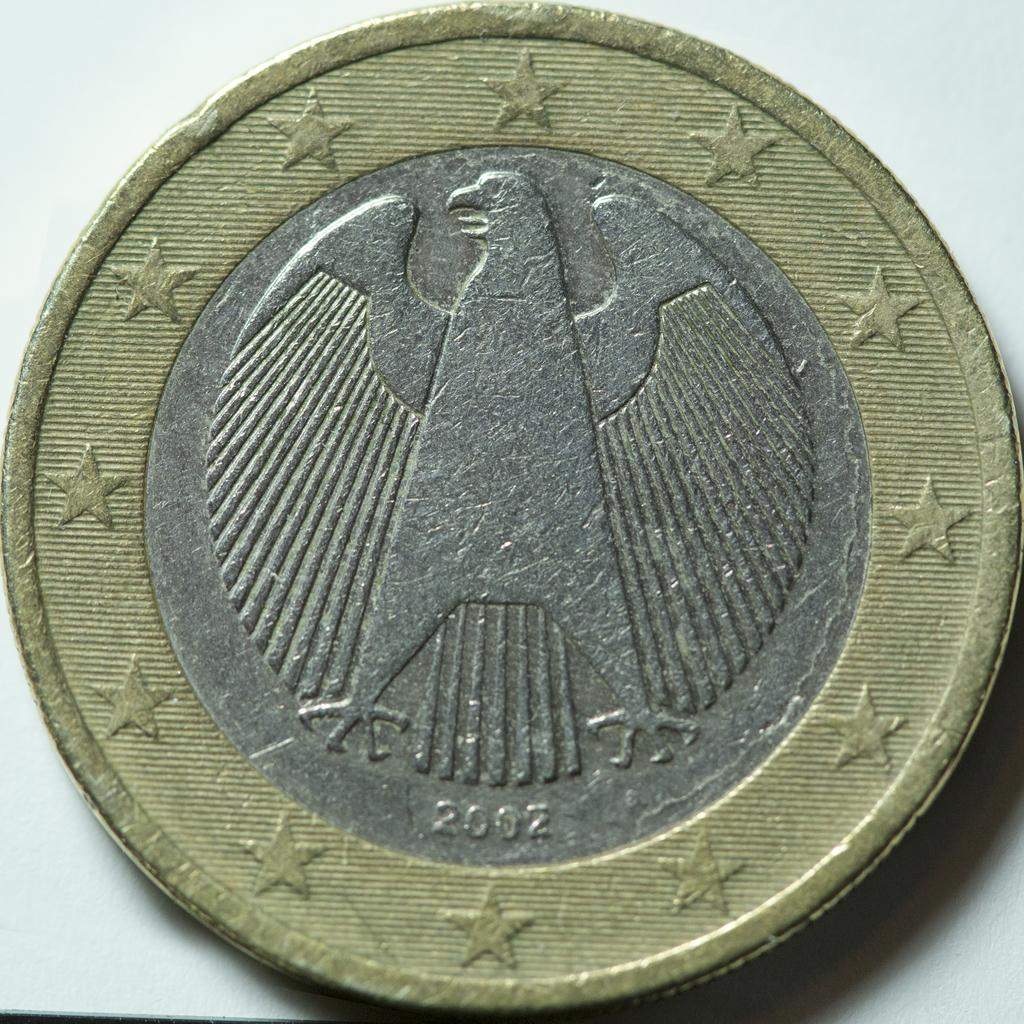<image>
Give a short and clear explanation of the subsequent image. The back of this Euro coin shows that it is from 2002. 